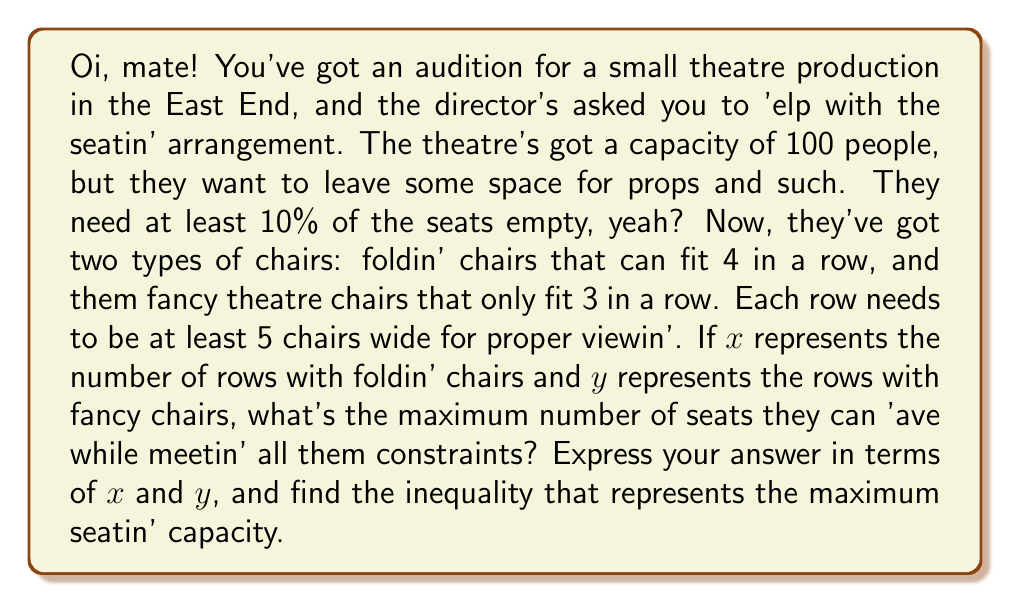Give your solution to this math problem. Right, let's break this down step by step, shall we?

1) First, let's define our variables:
   $x$ = number of rows with folding chairs (4 per row)
   $y$ = number of rows with fancy chairs (3 per row)

2) Now, each row needs to be at least 5 chairs wide. This gives us our first inequality:
   $$4x + 3y \geq 5(x + y)$$

3) The total number of seats is:
   $$4x + 3y$$

4) But remember, they need at least 10% of the seats empty. So the maximum number of occupied seats is 90% of the total. This gives us our second inequality:
   $$0.9(4x + 3y) \leq 100$$

5) Simplifying this:
   $$3.6x + 2.7y \leq 100$$

6) Now, we want to maximize the number of seats, which is $4x + 3y$, subject to these constraints.

7) The first inequality can be rearranged to:
   $$x + 3y \geq 5x + 5y$$
   $$-4x + -2y \geq 0$$
   $$2x + y \leq 0$$

8) So our system of inequalities is:
   $$2x + y \leq 0$$
   $$3.6x + 2.7y \leq 100$$
   $$x \geq 0, y \geq 0$$ (since we can't have negative rows)

9) The maximum number of seats will be at the point where these inequalities intersect, subject to the non-negativity constraints.
Answer: The maximum number of seats is given by the expression $4x + 3y$, subject to the constraints:

$$2x + y \leq 0$$
$$3.6x + 2.7y \leq 100$$
$$x \geq 0, y \geq 0$$

The optimal solution would be found at the intersection of these inequalities, which can be solved using linear programming techniques. 